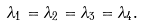Convert formula to latex. <formula><loc_0><loc_0><loc_500><loc_500>\lambda _ { 1 } = \lambda _ { 2 } = \lambda _ { 3 } = \lambda _ { 4 } .</formula> 